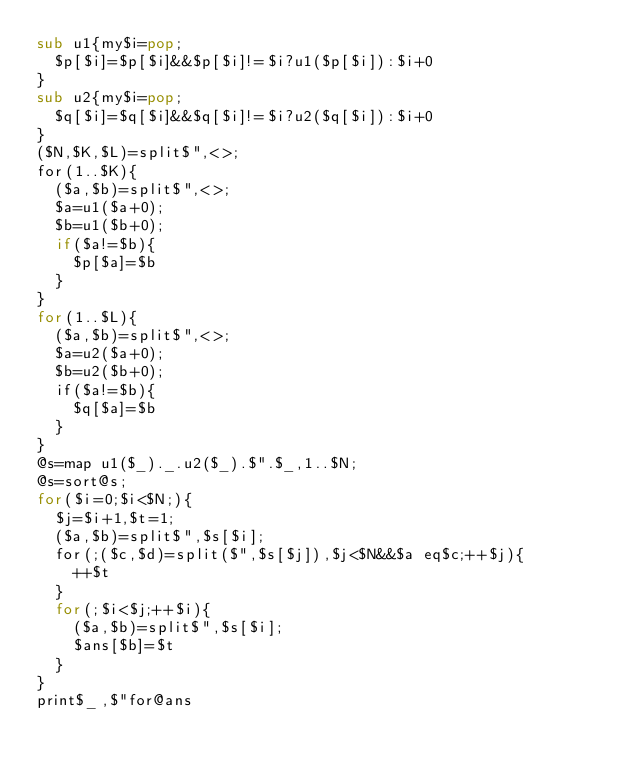<code> <loc_0><loc_0><loc_500><loc_500><_Perl_>sub u1{my$i=pop;
	$p[$i]=$p[$i]&&$p[$i]!=$i?u1($p[$i]):$i+0
}
sub u2{my$i=pop;
	$q[$i]=$q[$i]&&$q[$i]!=$i?u2($q[$i]):$i+0
}
($N,$K,$L)=split$",<>;
for(1..$K){
	($a,$b)=split$",<>;
	$a=u1($a+0);
	$b=u1($b+0);
	if($a!=$b){
		$p[$a]=$b
	}
}
for(1..$L){
	($a,$b)=split$",<>;
	$a=u2($a+0);
	$b=u2($b+0);
	if($a!=$b){
		$q[$a]=$b
	}
}
@s=map u1($_)._.u2($_).$".$_,1..$N;
@s=sort@s;
for($i=0;$i<$N;){
	$j=$i+1,$t=1;
	($a,$b)=split$",$s[$i];
	for(;($c,$d)=split($",$s[$j]),$j<$N&&$a eq$c;++$j){
		++$t
	}
	for(;$i<$j;++$i){
		($a,$b)=split$",$s[$i];
		$ans[$b]=$t
	}
}
print$_,$"for@ans
</code> 